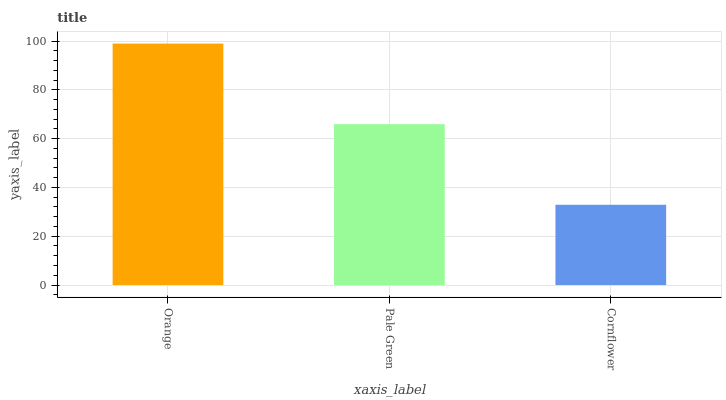Is Cornflower the minimum?
Answer yes or no. Yes. Is Orange the maximum?
Answer yes or no. Yes. Is Pale Green the minimum?
Answer yes or no. No. Is Pale Green the maximum?
Answer yes or no. No. Is Orange greater than Pale Green?
Answer yes or no. Yes. Is Pale Green less than Orange?
Answer yes or no. Yes. Is Pale Green greater than Orange?
Answer yes or no. No. Is Orange less than Pale Green?
Answer yes or no. No. Is Pale Green the high median?
Answer yes or no. Yes. Is Pale Green the low median?
Answer yes or no. Yes. Is Cornflower the high median?
Answer yes or no. No. Is Cornflower the low median?
Answer yes or no. No. 